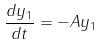<formula> <loc_0><loc_0><loc_500><loc_500>\frac { d y _ { 1 } } { d t } = - A y _ { 1 }</formula> 